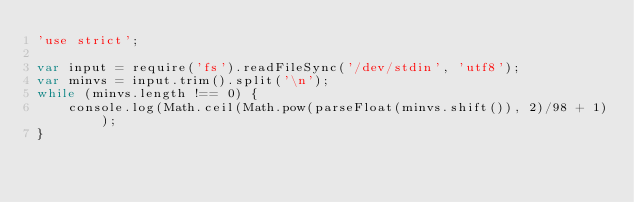<code> <loc_0><loc_0><loc_500><loc_500><_JavaScript_>'use strict';

var input = require('fs').readFileSync('/dev/stdin', 'utf8');
var minvs = input.trim().split('\n');
while (minvs.length !== 0) {
	console.log(Math.ceil(Math.pow(parseFloat(minvs.shift()), 2)/98 + 1));
}</code> 